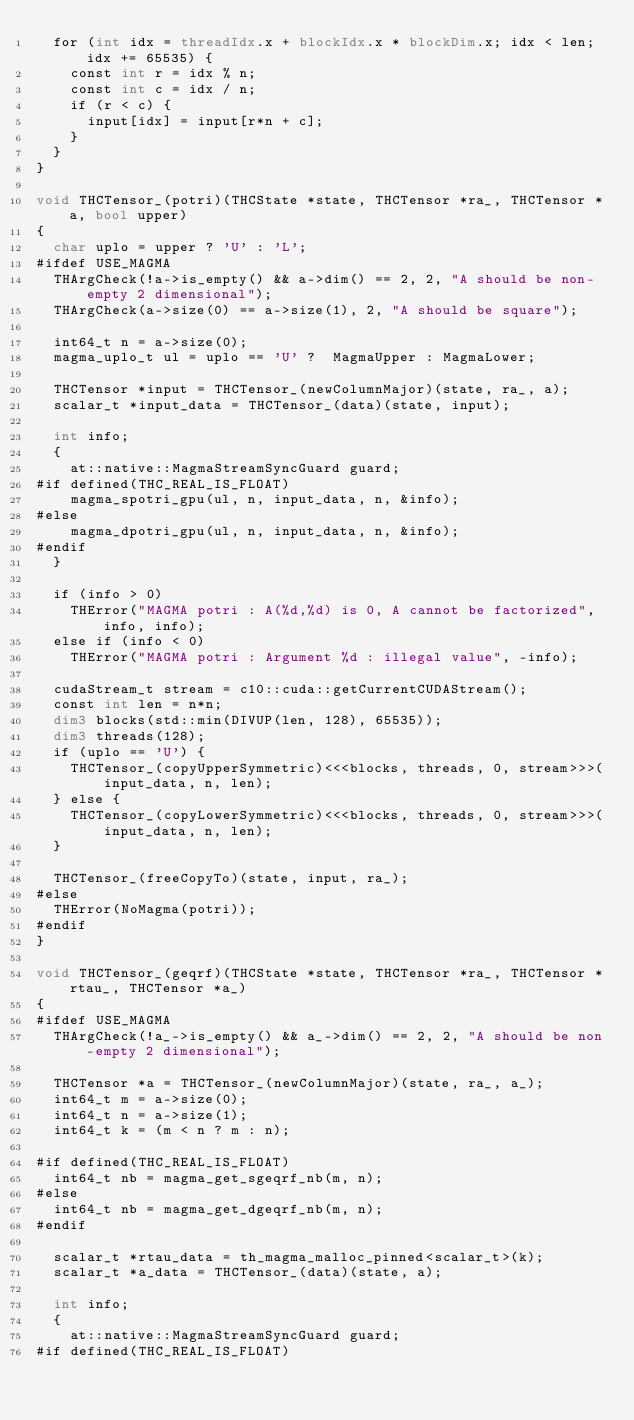Convert code to text. <code><loc_0><loc_0><loc_500><loc_500><_Cuda_>  for (int idx = threadIdx.x + blockIdx.x * blockDim.x; idx < len; idx += 65535) {
    const int r = idx % n;
    const int c = idx / n;
    if (r < c) {
      input[idx] = input[r*n + c];
    }
  }
}

void THCTensor_(potri)(THCState *state, THCTensor *ra_, THCTensor *a, bool upper)
{
  char uplo = upper ? 'U' : 'L';
#ifdef USE_MAGMA
  THArgCheck(!a->is_empty() && a->dim() == 2, 2, "A should be non-empty 2 dimensional");
  THArgCheck(a->size(0) == a->size(1), 2, "A should be square");

  int64_t n = a->size(0);
  magma_uplo_t ul = uplo == 'U' ?  MagmaUpper : MagmaLower;

  THCTensor *input = THCTensor_(newColumnMajor)(state, ra_, a);
  scalar_t *input_data = THCTensor_(data)(state, input);

  int info;
  {
    at::native::MagmaStreamSyncGuard guard;
#if defined(THC_REAL_IS_FLOAT)
    magma_spotri_gpu(ul, n, input_data, n, &info);
#else
    magma_dpotri_gpu(ul, n, input_data, n, &info);
#endif
  }

  if (info > 0)
    THError("MAGMA potri : A(%d,%d) is 0, A cannot be factorized", info, info);
  else if (info < 0)
    THError("MAGMA potri : Argument %d : illegal value", -info);

  cudaStream_t stream = c10::cuda::getCurrentCUDAStream();
  const int len = n*n;
  dim3 blocks(std::min(DIVUP(len, 128), 65535));
  dim3 threads(128);
  if (uplo == 'U') {
    THCTensor_(copyUpperSymmetric)<<<blocks, threads, 0, stream>>>(input_data, n, len);
  } else {
    THCTensor_(copyLowerSymmetric)<<<blocks, threads, 0, stream>>>(input_data, n, len);
  }

  THCTensor_(freeCopyTo)(state, input, ra_);
#else
  THError(NoMagma(potri));
#endif
}

void THCTensor_(geqrf)(THCState *state, THCTensor *ra_, THCTensor *rtau_, THCTensor *a_)
{
#ifdef USE_MAGMA
  THArgCheck(!a_->is_empty() && a_->dim() == 2, 2, "A should be non-empty 2 dimensional");

  THCTensor *a = THCTensor_(newColumnMajor)(state, ra_, a_);
  int64_t m = a->size(0);
  int64_t n = a->size(1);
  int64_t k = (m < n ? m : n);

#if defined(THC_REAL_IS_FLOAT)
  int64_t nb = magma_get_sgeqrf_nb(m, n);
#else
  int64_t nb = magma_get_dgeqrf_nb(m, n);
#endif

  scalar_t *rtau_data = th_magma_malloc_pinned<scalar_t>(k);
  scalar_t *a_data = THCTensor_(data)(state, a);

  int info;
  {
    at::native::MagmaStreamSyncGuard guard;
#if defined(THC_REAL_IS_FLOAT)</code> 